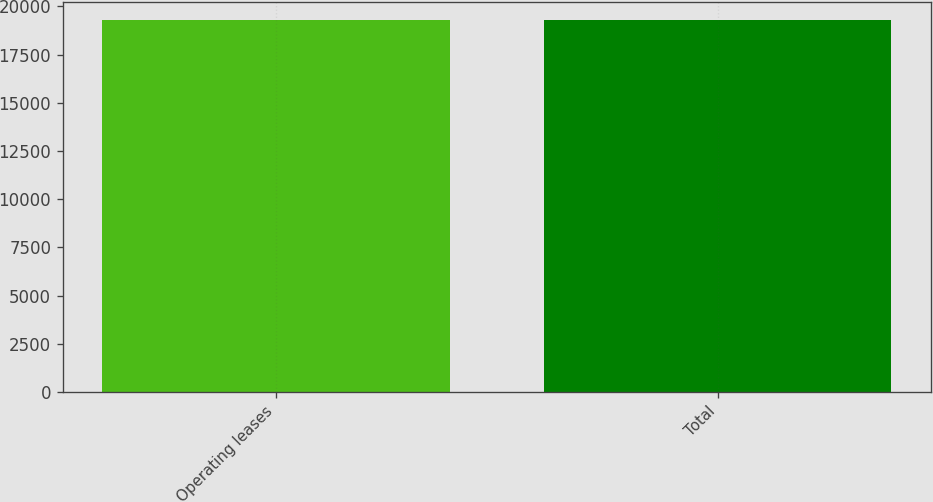Convert chart. <chart><loc_0><loc_0><loc_500><loc_500><bar_chart><fcel>Operating leases<fcel>Total<nl><fcel>19278<fcel>19278.1<nl></chart> 